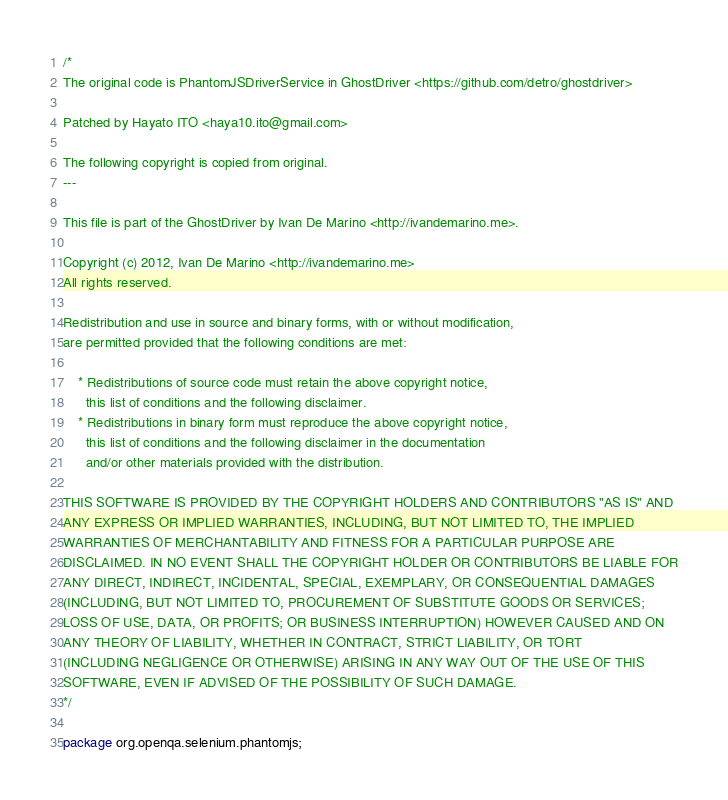Convert code to text. <code><loc_0><loc_0><loc_500><loc_500><_Java_>/*
The original code is PhantomJSDriverService in GhostDriver <https://github.com/detro/ghostdriver> 

Patched by Hayato ITO <haya10.ito@gmail.com>

The following copyright is copied from original.
---

This file is part of the GhostDriver by Ivan De Marino <http://ivandemarino.me>.

Copyright (c) 2012, Ivan De Marino <http://ivandemarino.me>
All rights reserved.

Redistribution and use in source and binary forms, with or without modification,
are permitted provided that the following conditions are met:

    * Redistributions of source code must retain the above copyright notice,
      this list of conditions and the following disclaimer.
    * Redistributions in binary form must reproduce the above copyright notice,
      this list of conditions and the following disclaimer in the documentation
      and/or other materials provided with the distribution.

THIS SOFTWARE IS PROVIDED BY THE COPYRIGHT HOLDERS AND CONTRIBUTORS "AS IS" AND
ANY EXPRESS OR IMPLIED WARRANTIES, INCLUDING, BUT NOT LIMITED TO, THE IMPLIED
WARRANTIES OF MERCHANTABILITY AND FITNESS FOR A PARTICULAR PURPOSE ARE
DISCLAIMED. IN NO EVENT SHALL THE COPYRIGHT HOLDER OR CONTRIBUTORS BE LIABLE FOR
ANY DIRECT, INDIRECT, INCIDENTAL, SPECIAL, EXEMPLARY, OR CONSEQUENTIAL DAMAGES
(INCLUDING, BUT NOT LIMITED TO, PROCUREMENT OF SUBSTITUTE GOODS OR SERVICES;
LOSS OF USE, DATA, OR PROFITS; OR BUSINESS INTERRUPTION) HOWEVER CAUSED AND ON
ANY THEORY OF LIABILITY, WHETHER IN CONTRACT, STRICT LIABILITY, OR TORT
(INCLUDING NEGLIGENCE OR OTHERWISE) ARISING IN ANY WAY OUT OF THE USE OF THIS
SOFTWARE, EVEN IF ADVISED OF THE POSSIBILITY OF SUCH DAMAGE.
*/

package org.openqa.selenium.phantomjs;
</code> 